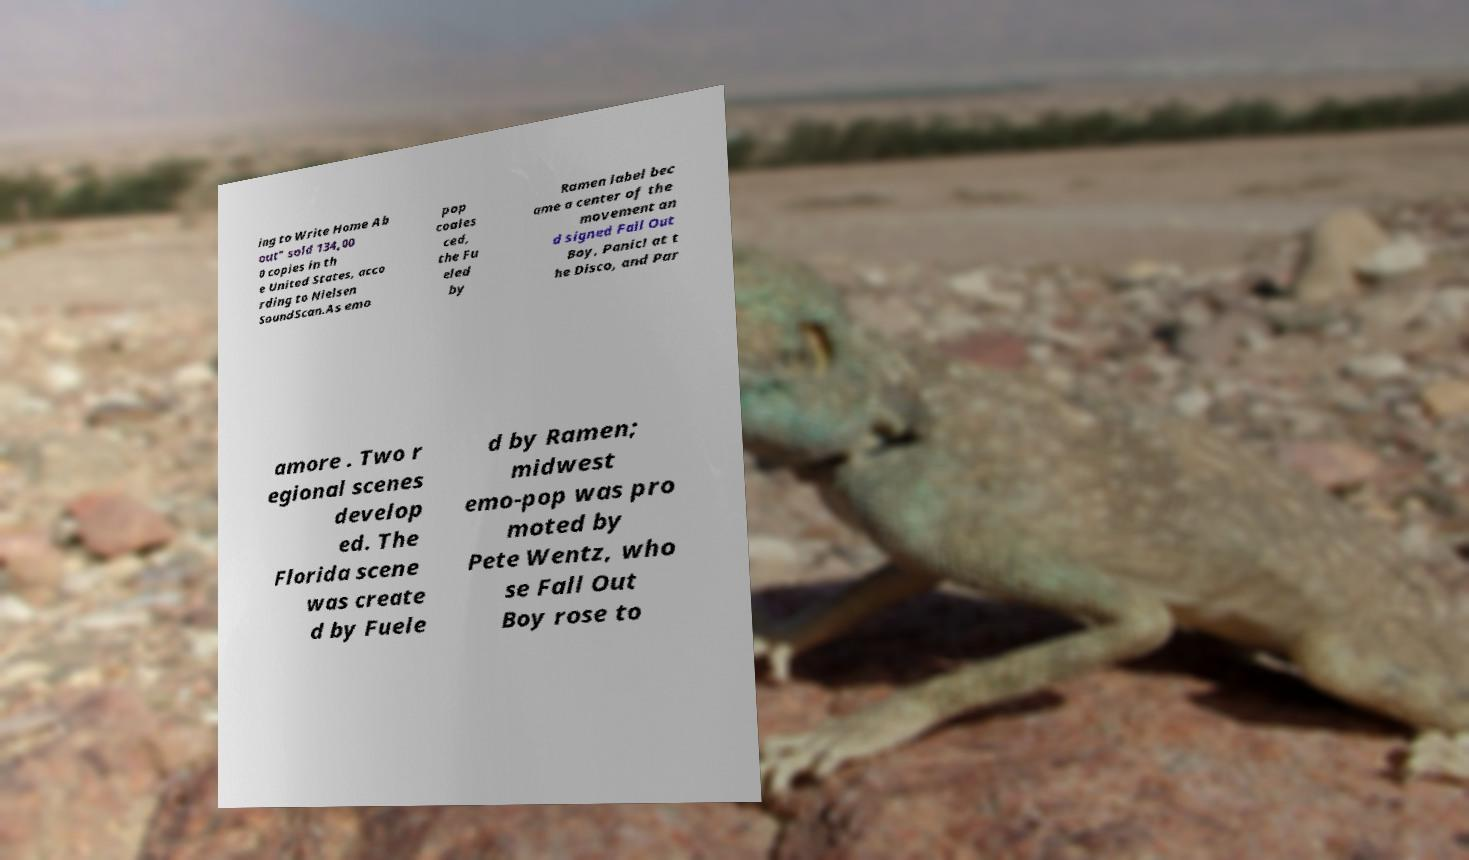Can you accurately transcribe the text from the provided image for me? ing to Write Home Ab out" sold 134,00 0 copies in th e United States, acco rding to Nielsen SoundScan.As emo pop coales ced, the Fu eled by Ramen label bec ame a center of the movement an d signed Fall Out Boy, Panic! at t he Disco, and Par amore . Two r egional scenes develop ed. The Florida scene was create d by Fuele d by Ramen; midwest emo-pop was pro moted by Pete Wentz, who se Fall Out Boy rose to 